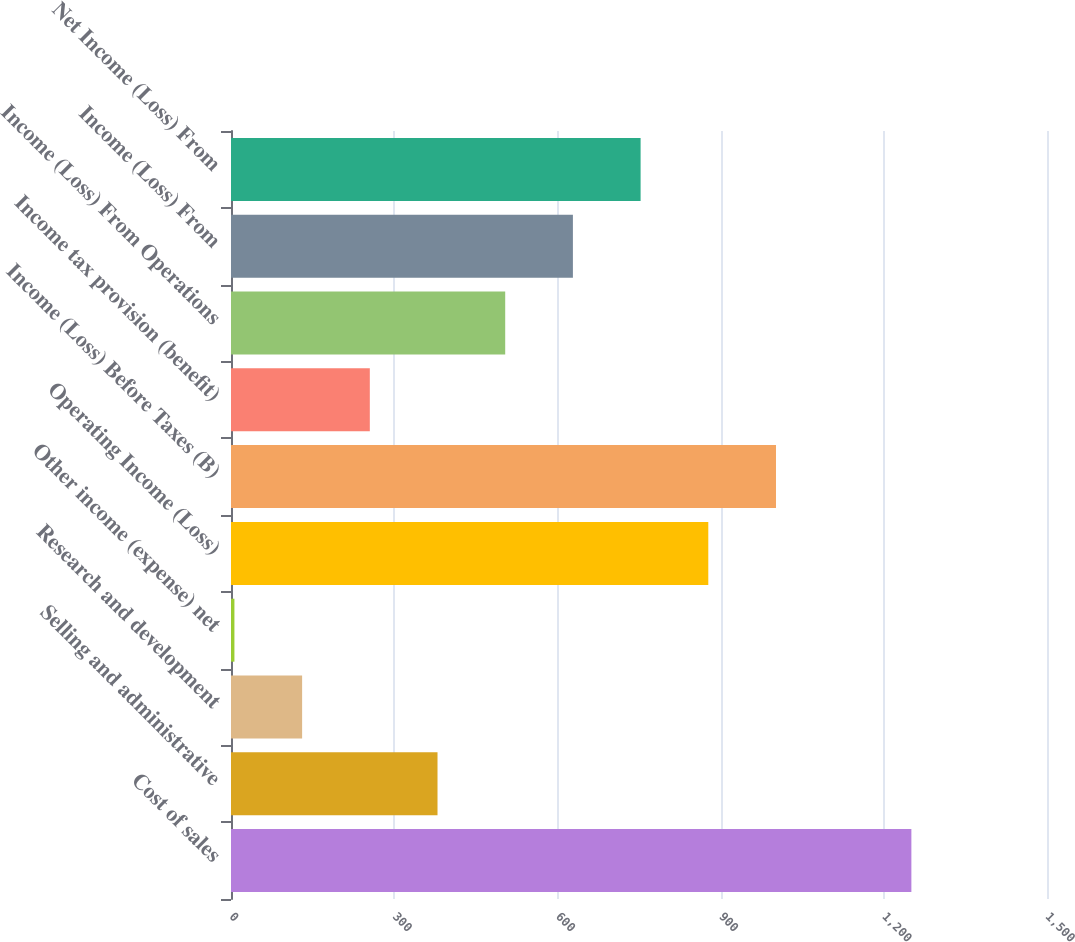Convert chart to OTSL. <chart><loc_0><loc_0><loc_500><loc_500><bar_chart><fcel>Cost of sales<fcel>Selling and administrative<fcel>Research and development<fcel>Other income (expense) net<fcel>Operating Income (Loss)<fcel>Income (Loss) Before Taxes (B)<fcel>Income tax provision (benefit)<fcel>Income (Loss) From Operations<fcel>Income (Loss) From<fcel>Net Income (Loss) From<nl><fcel>1250.7<fcel>379.62<fcel>130.74<fcel>6.3<fcel>877.38<fcel>1001.82<fcel>255.18<fcel>504.06<fcel>628.5<fcel>752.94<nl></chart> 